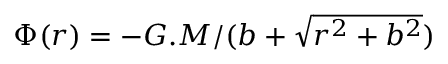Convert formula to latex. <formula><loc_0><loc_0><loc_500><loc_500>\Phi ( r ) = - { G . M } / { ( b + \sqrt { r ^ { 2 } + b ^ { 2 } } ) }</formula> 